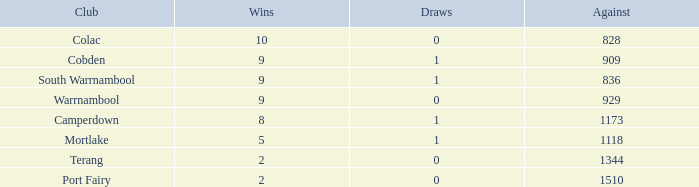What is the sum of losses for Against values over 1510? None. 